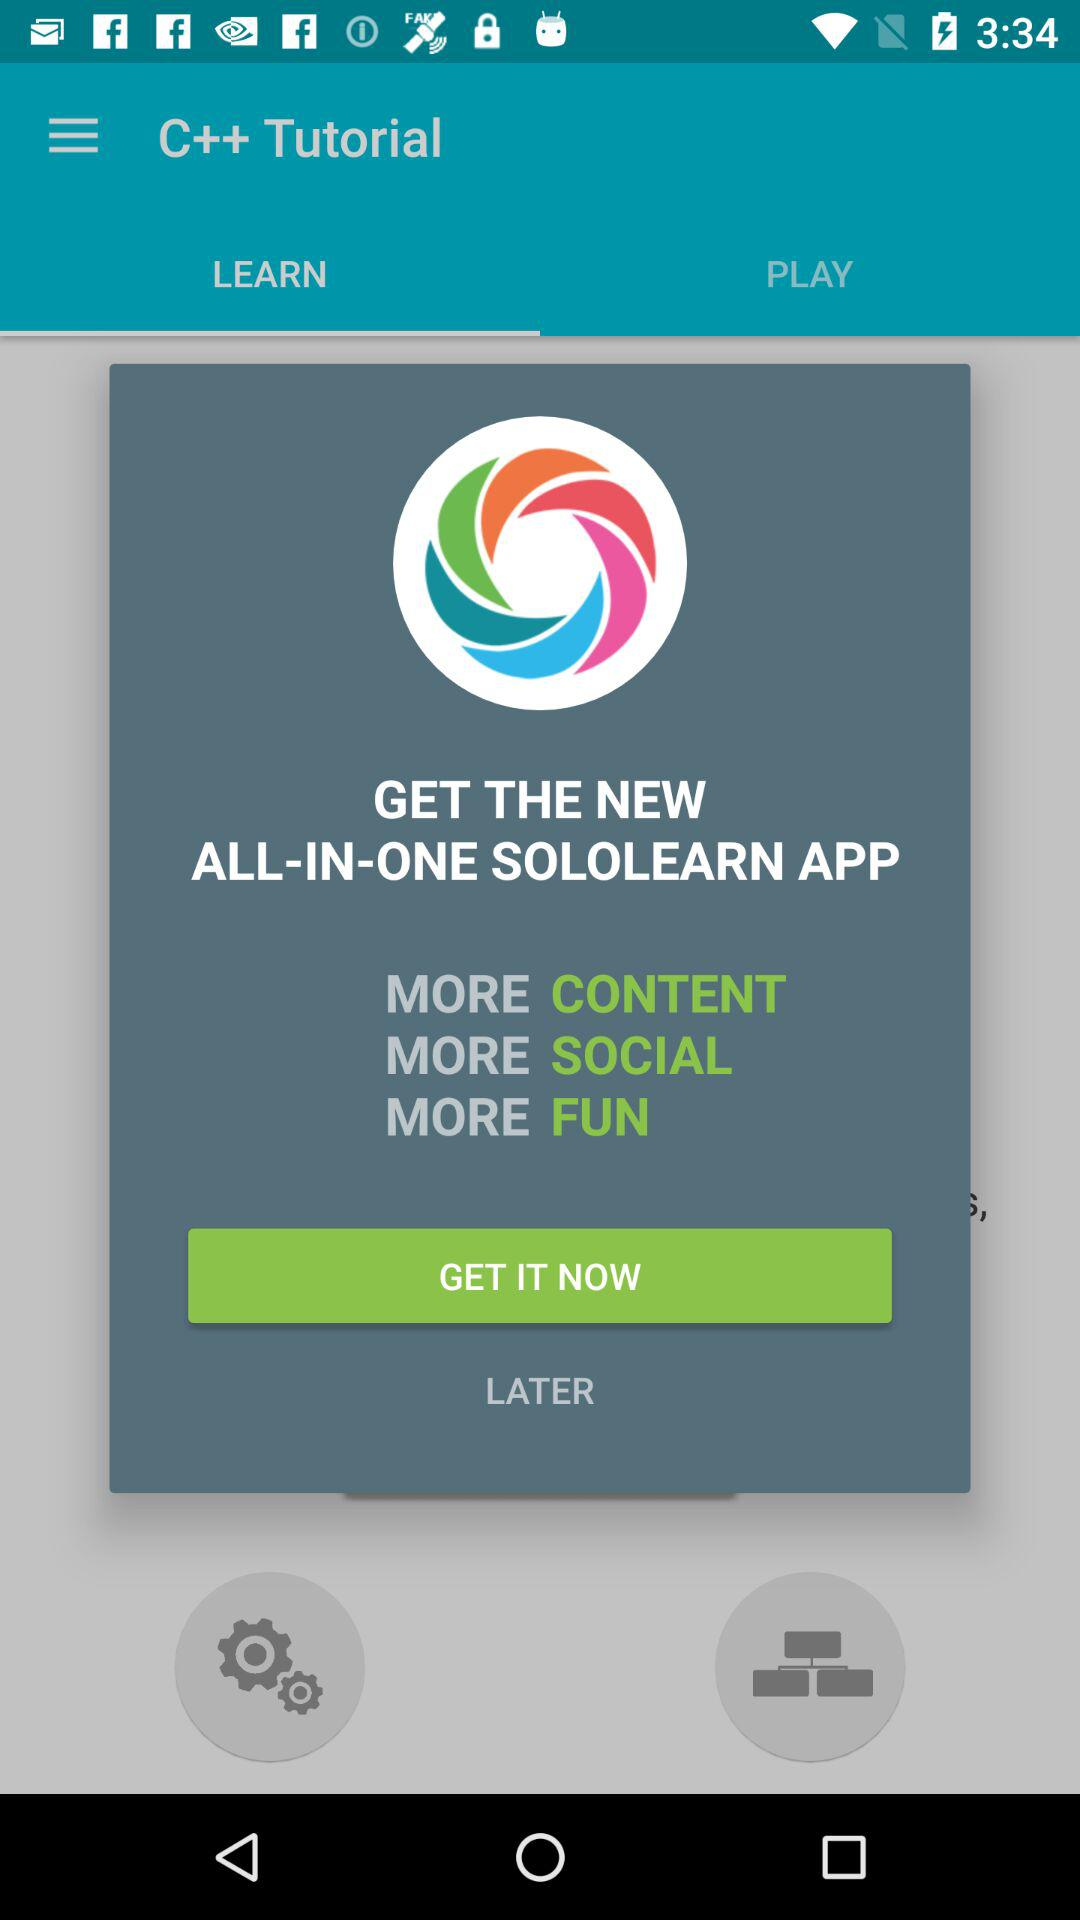Which tab has been selected? The selected tab is "LEARN". 